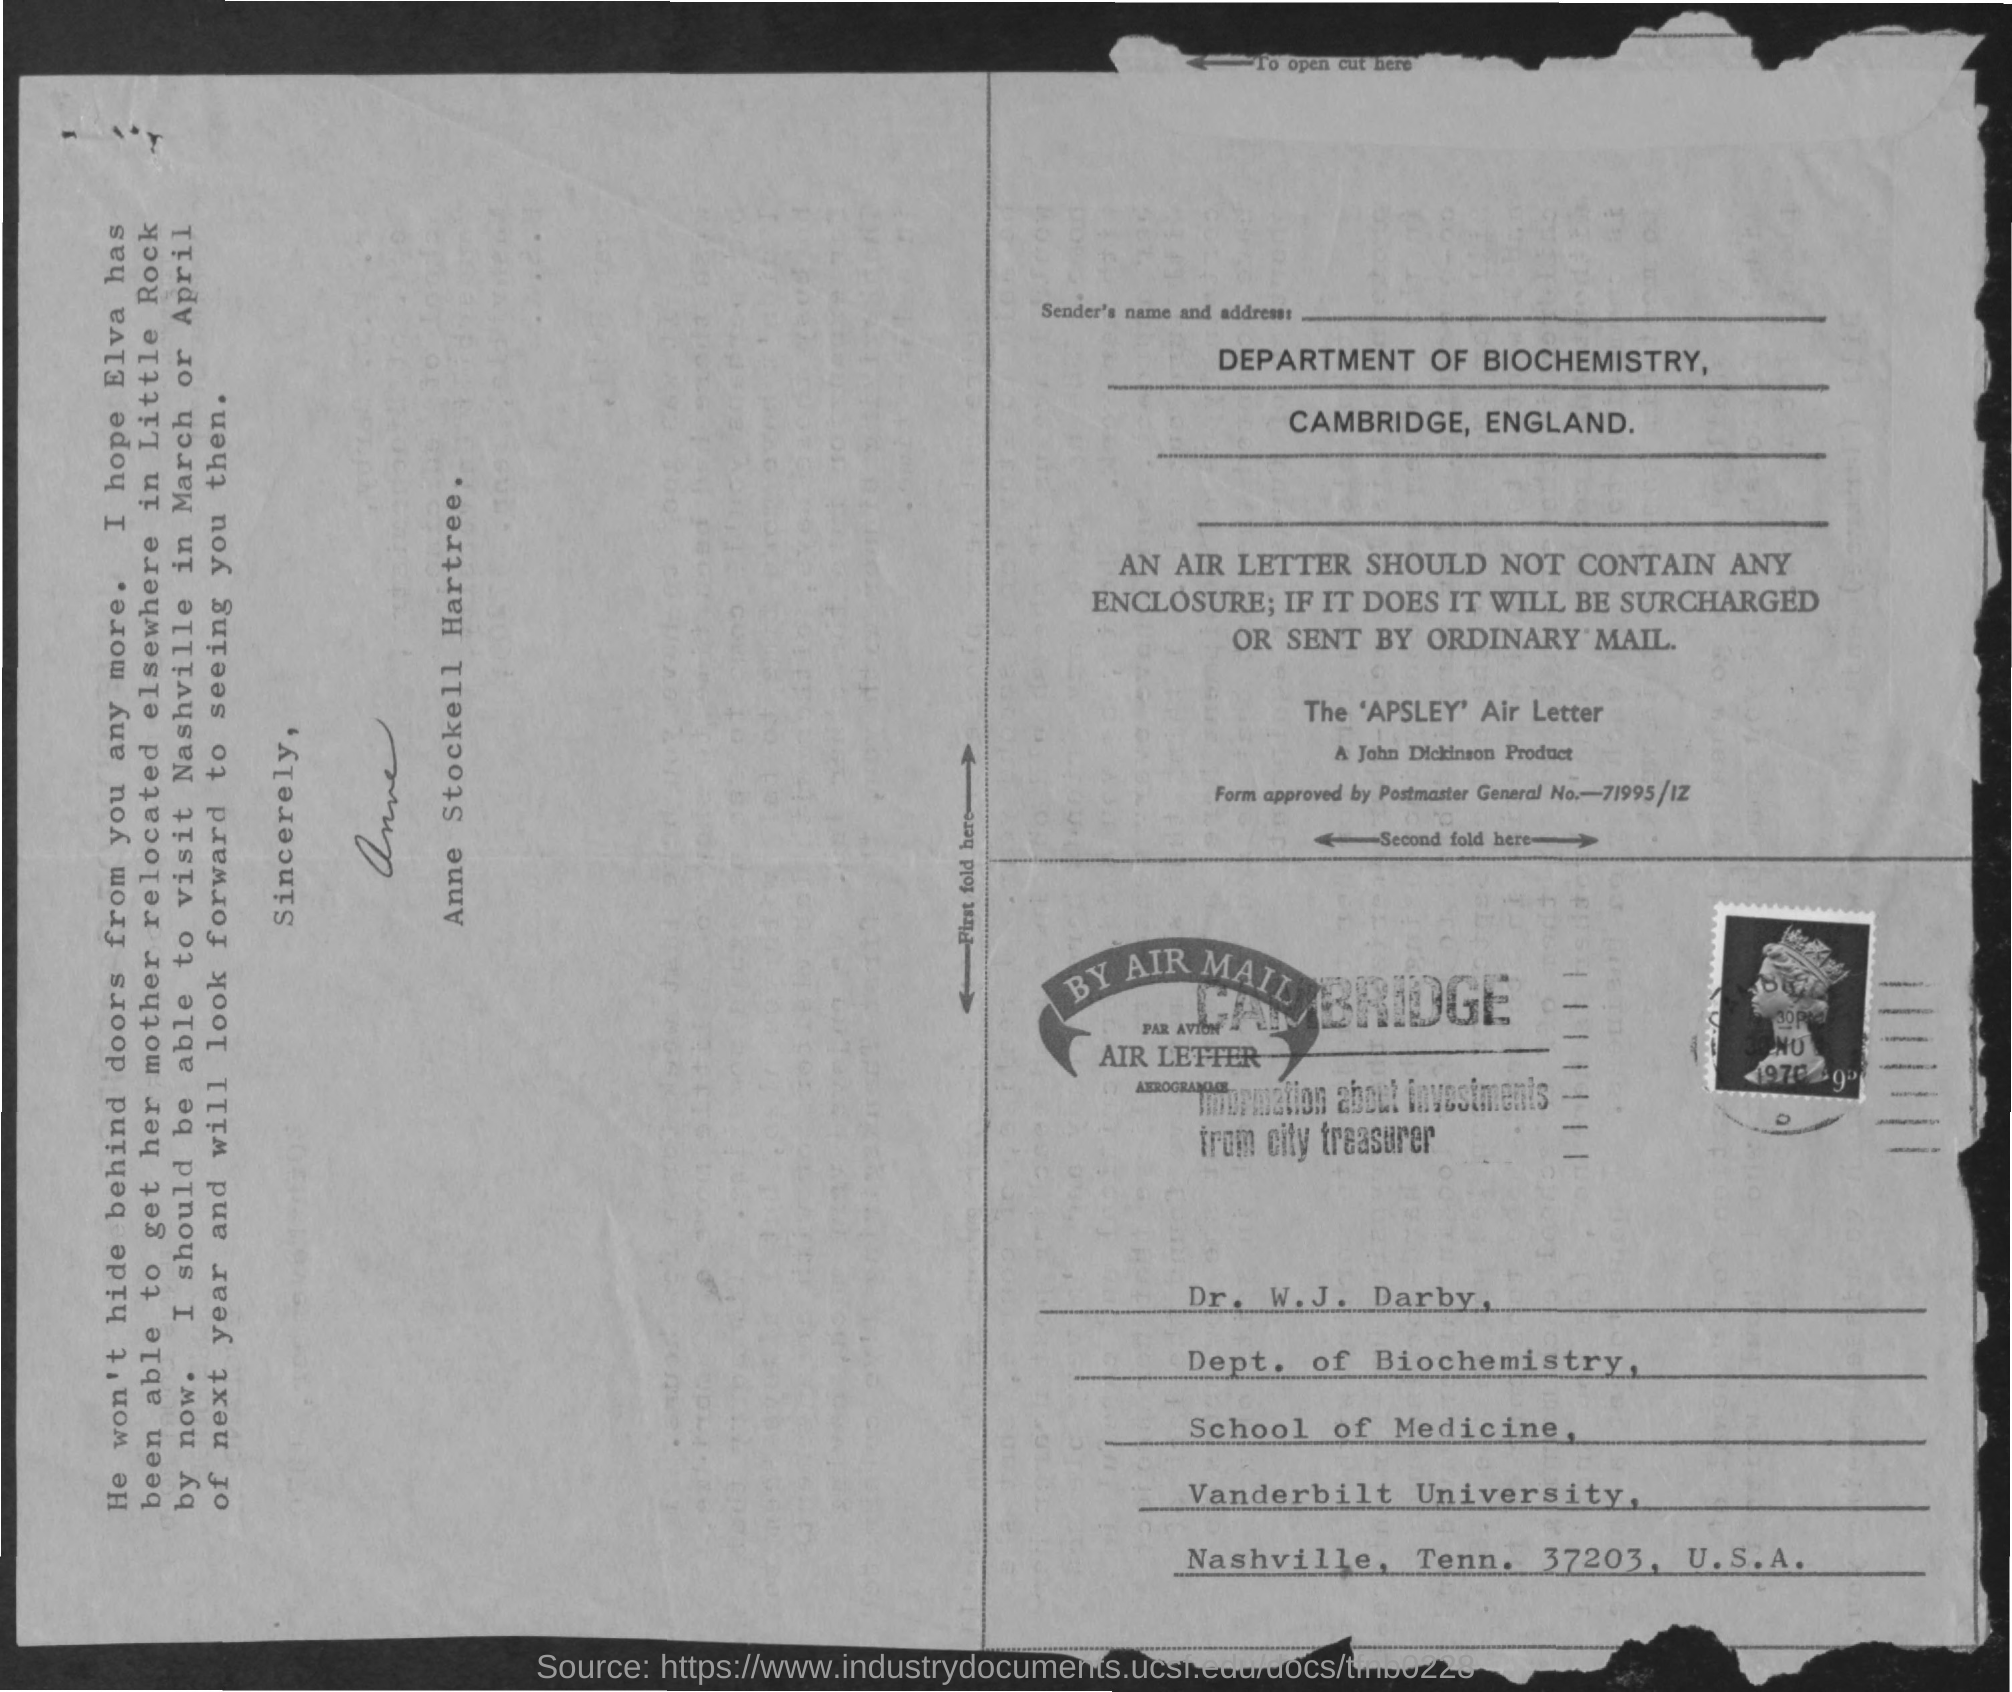List a handful of essential elements in this visual. The signer of the letter is Anne Stockell Hartree. 